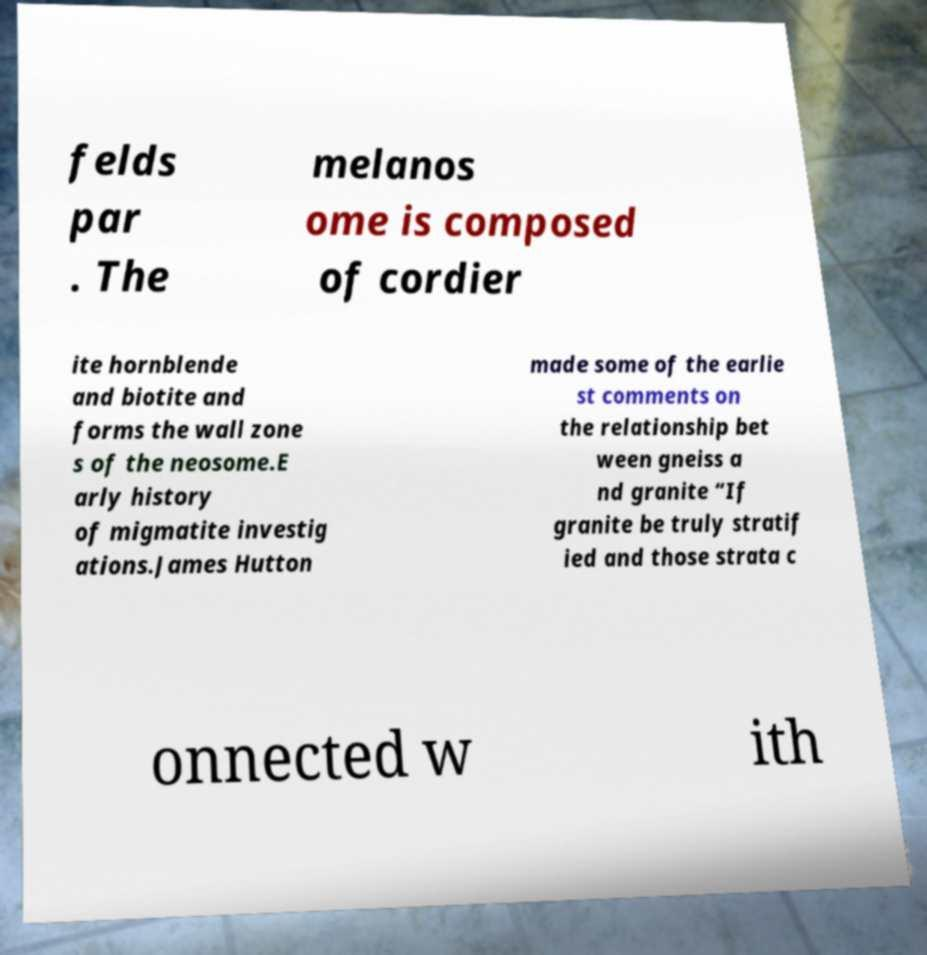Could you extract and type out the text from this image? felds par . The melanos ome is composed of cordier ite hornblende and biotite and forms the wall zone s of the neosome.E arly history of migmatite investig ations.James Hutton made some of the earlie st comments on the relationship bet ween gneiss a nd granite “If granite be truly stratif ied and those strata c onnected w ith 